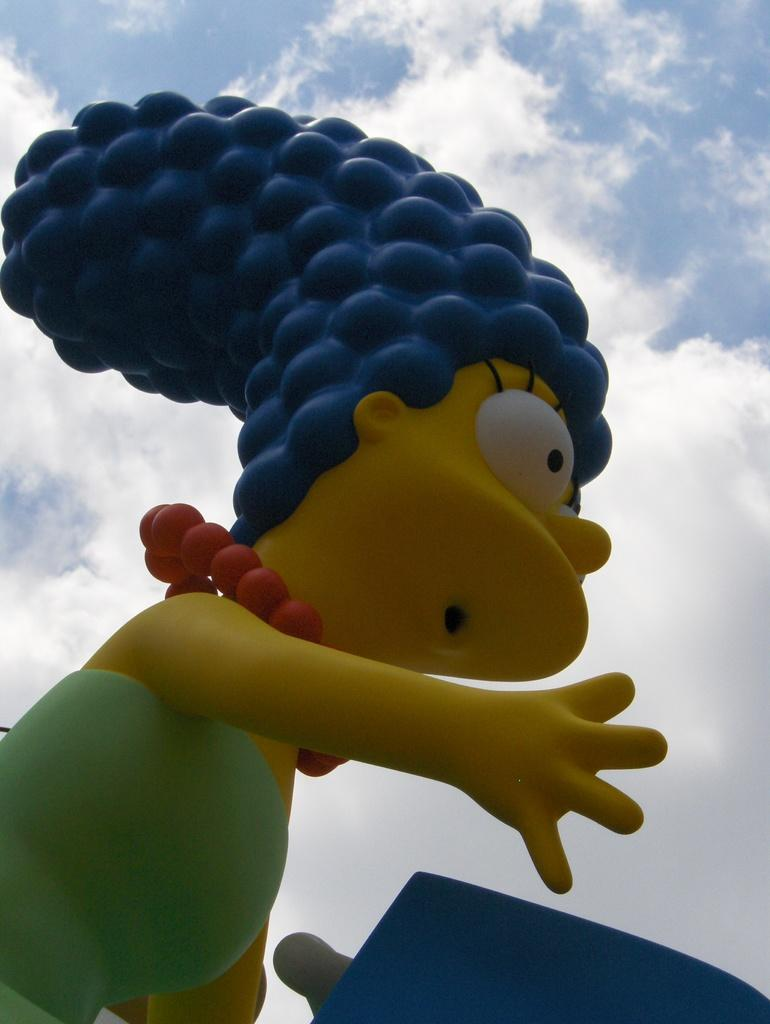What type of artwork is featured in the image? There is a sculpture of a cartoon character in the image. What can be seen in the background of the image? The sky is visible in the background of the image. What type of glove is the cartoon character wearing in the image? The image does not show the cartoon character wearing a glove, as it only features a sculpture of the character. 